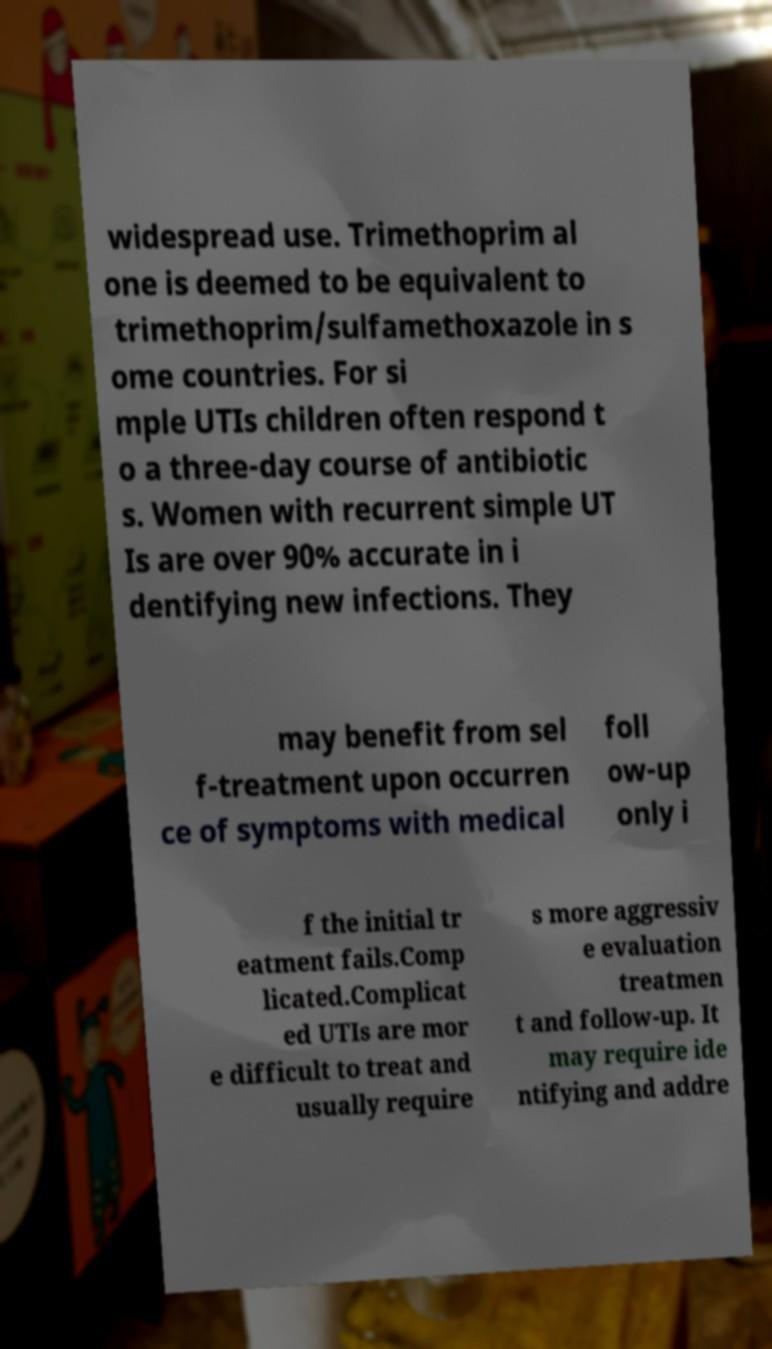There's text embedded in this image that I need extracted. Can you transcribe it verbatim? widespread use. Trimethoprim al one is deemed to be equivalent to trimethoprim/sulfamethoxazole in s ome countries. For si mple UTIs children often respond t o a three-day course of antibiotic s. Women with recurrent simple UT Is are over 90% accurate in i dentifying new infections. They may benefit from sel f-treatment upon occurren ce of symptoms with medical foll ow-up only i f the initial tr eatment fails.Comp licated.Complicat ed UTIs are mor e difficult to treat and usually require s more aggressiv e evaluation treatmen t and follow-up. It may require ide ntifying and addre 